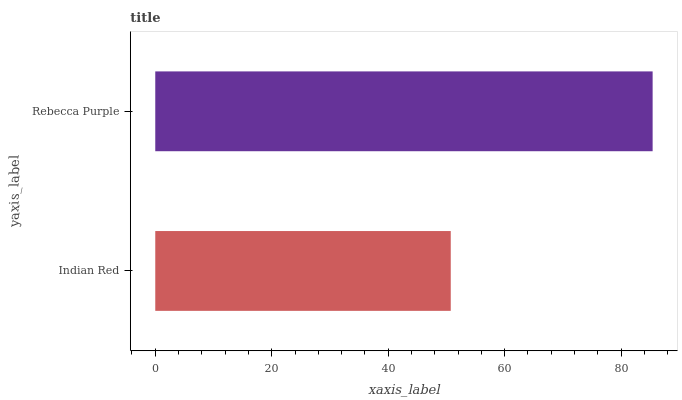Is Indian Red the minimum?
Answer yes or no. Yes. Is Rebecca Purple the maximum?
Answer yes or no. Yes. Is Rebecca Purple the minimum?
Answer yes or no. No. Is Rebecca Purple greater than Indian Red?
Answer yes or no. Yes. Is Indian Red less than Rebecca Purple?
Answer yes or no. Yes. Is Indian Red greater than Rebecca Purple?
Answer yes or no. No. Is Rebecca Purple less than Indian Red?
Answer yes or no. No. Is Rebecca Purple the high median?
Answer yes or no. Yes. Is Indian Red the low median?
Answer yes or no. Yes. Is Indian Red the high median?
Answer yes or no. No. Is Rebecca Purple the low median?
Answer yes or no. No. 